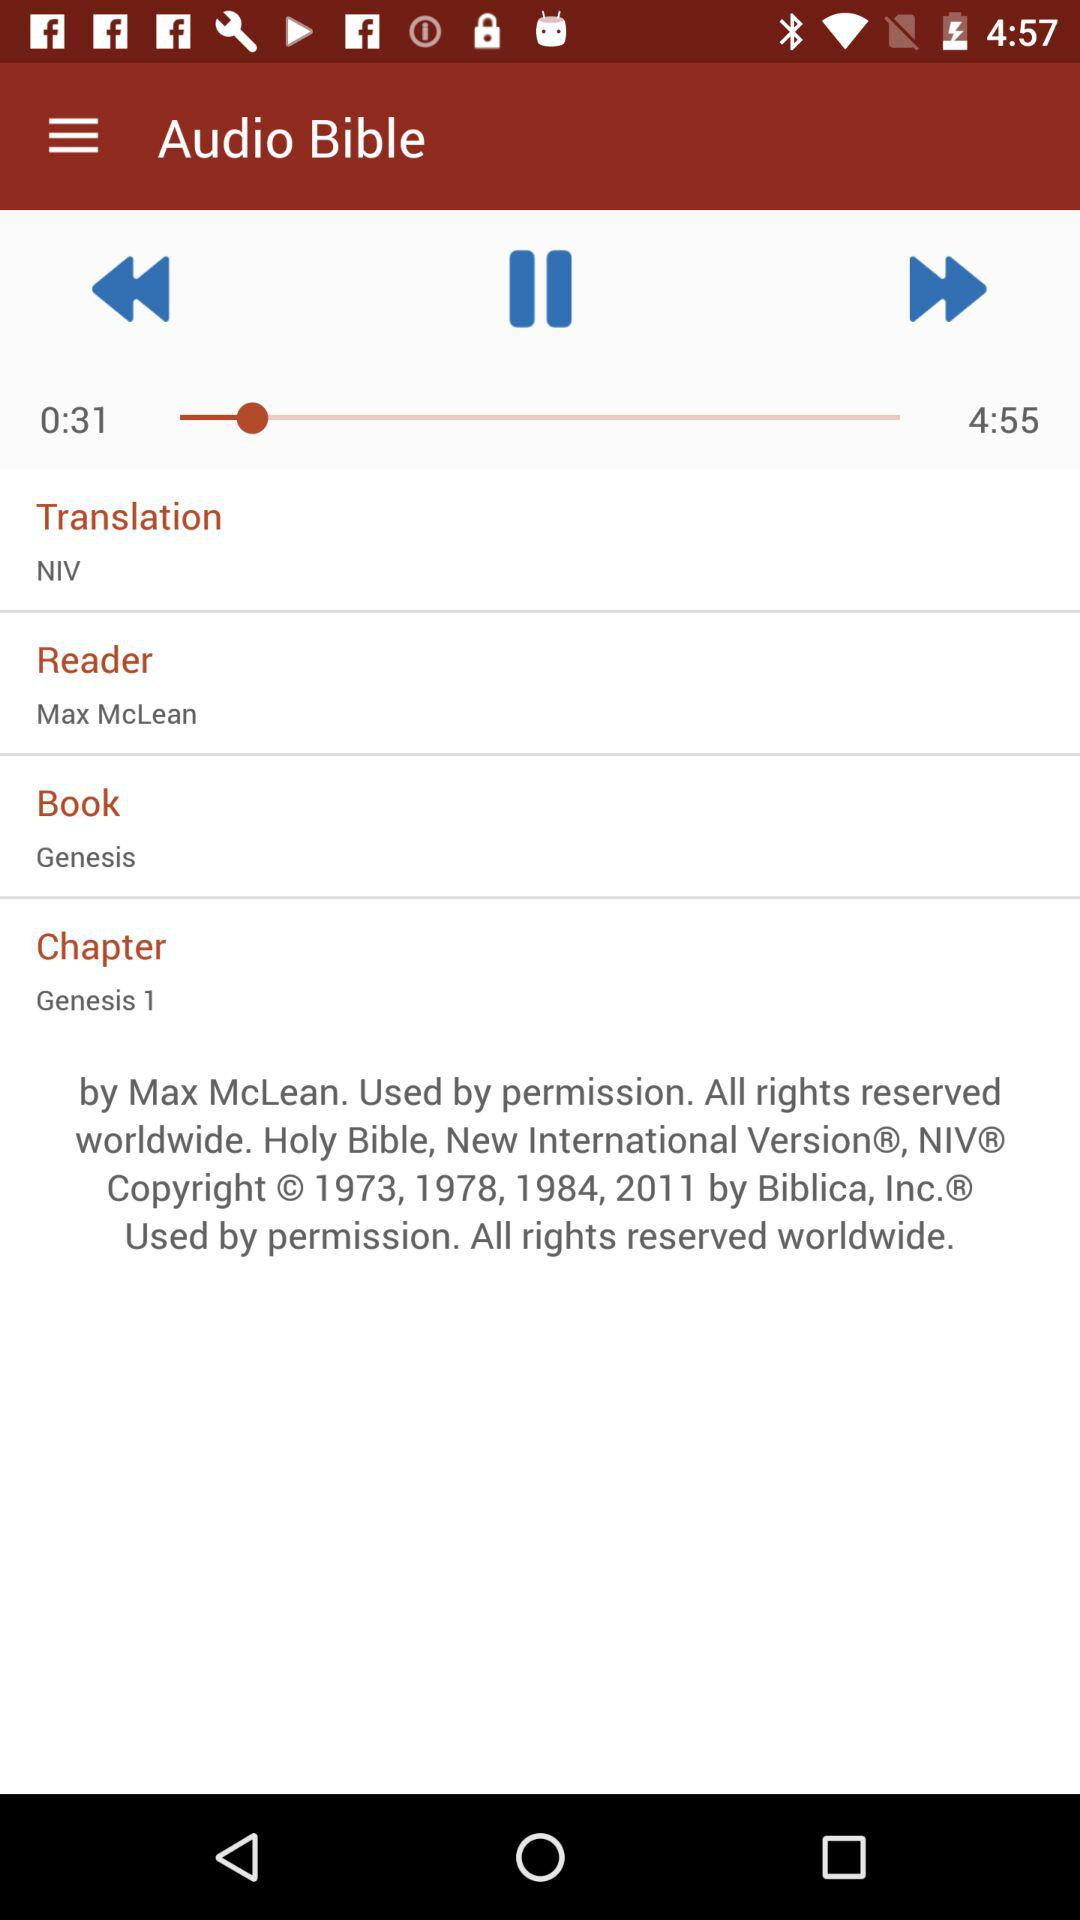What translation is used? The translation is "NIV". 